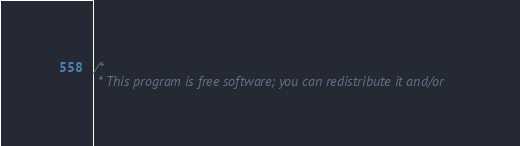Convert code to text. <code><loc_0><loc_0><loc_500><loc_500><_C_>/*
 * This program is free software; you can redistribute it and/or</code> 